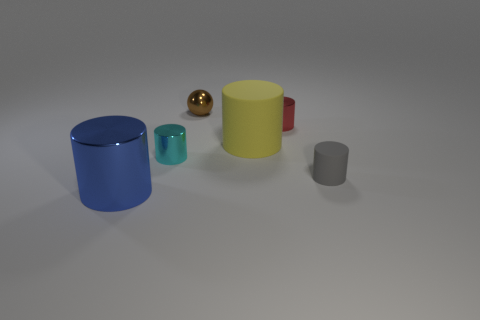What could be the context or setting for these objects? The context appears to be a neutral, minimalistic setting, possibly for the purpose of product visualization, a 3D modeling demonstration, or an artistic composition emphasizing simplicity and form. 